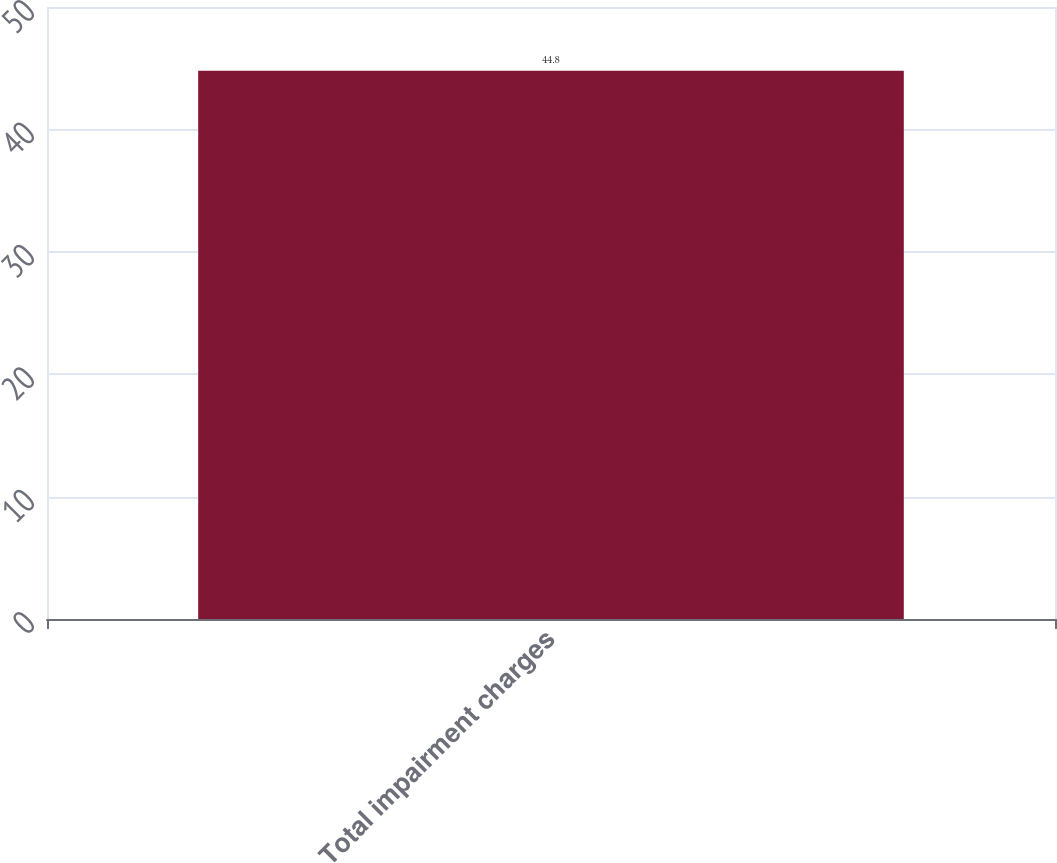<chart> <loc_0><loc_0><loc_500><loc_500><bar_chart><fcel>Total impairment charges<nl><fcel>44.8<nl></chart> 